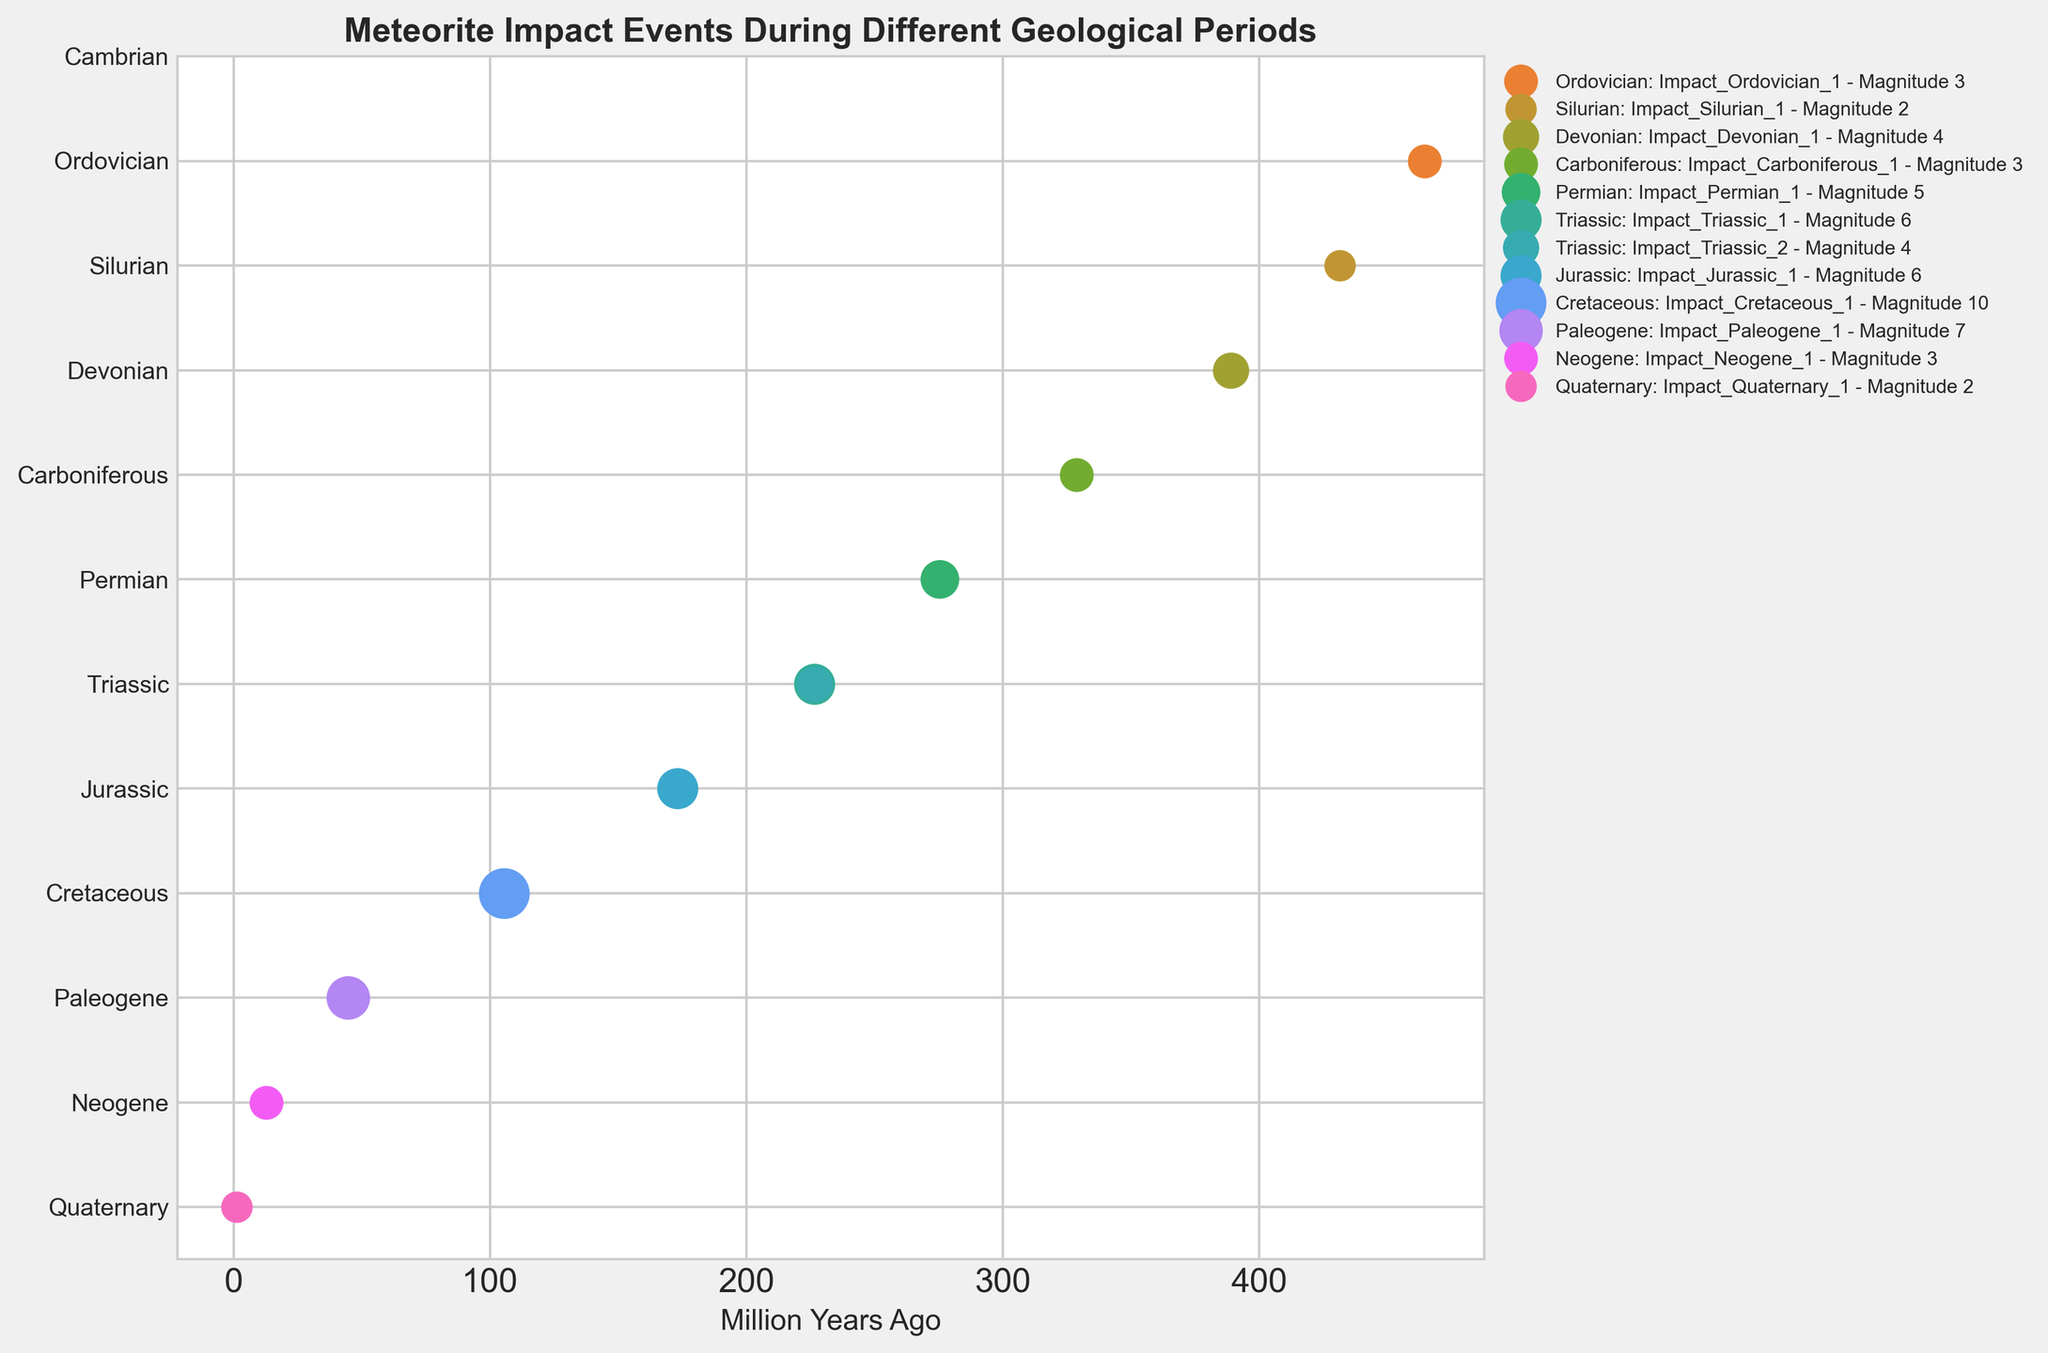How many impact events are recorded during the Triassic period? Count the number of events annotated in the Triassic period section of the plot. There are two events labeled Impact_Triassic_1 and Impact_Triassic_2.
Answer: 2 Which geological period has the impact event with the highest magnitude? Observe the magnitudes of the impact events annotated in the plot. The highest magnitude is 10, which occurs in the Cretaceous period.
Answer: Cretaceous What is the average magnitude of impact events recorded during the Jurassic period? Identify the magnitudes of the impact events in the Jurassic period. There is 1 event with a magnitude of 6. The average of a single value is the value itself, so: 6
Answer: 6 Are there more impact events in the Paleozoic era (Cambrian to Permian) or the Mesozoic era (Triassic to Cretaceous)? Count the total number of impact events in each era. The Paleozoic era has 5 events (excluding "No data" for Cambrian). The Mesozoic era has 4 events. So, Paleozoic has more impact events.
Answer: Paleozoic Which impact event in the plot has the smallest magnitude, and during which period did it occur? Observe the magnitudes of all the impact events and find the smallest value, which is 2. There are two such events, one in the Silurian period and one in the Quaternary period.
Answer: Silurian and Quaternary What is the difference in magnitude between the highest and the lowest recorded impact events? Find the highest magnitude (10) and the lowest magnitude (2) and calculate the difference: 10 - 2 = 8
Answer: 8 How many geological periods have more than one impact event recorded? Identify periods with multiple events by examining the plot. The Triassic period is the only one with more than one recorded impact (Impact_Triassic_1 and Impact_Triassic_2).
Answer: 1 During which period(s) is there no data about impact events? Locate any periods labeled as "No data". Only the Cambrian period has no data about impact events.
Answer: Cambrian By how many million years does the end time of the Ordovician period precede the start time of the Silurian period? The end of the Ordovician period is at 443.8 million years ago, and the start of the Silurian period is at 443.8 million years ago. The difference is 443.8 - 443.8 = 0 million years.
Answer: 0 